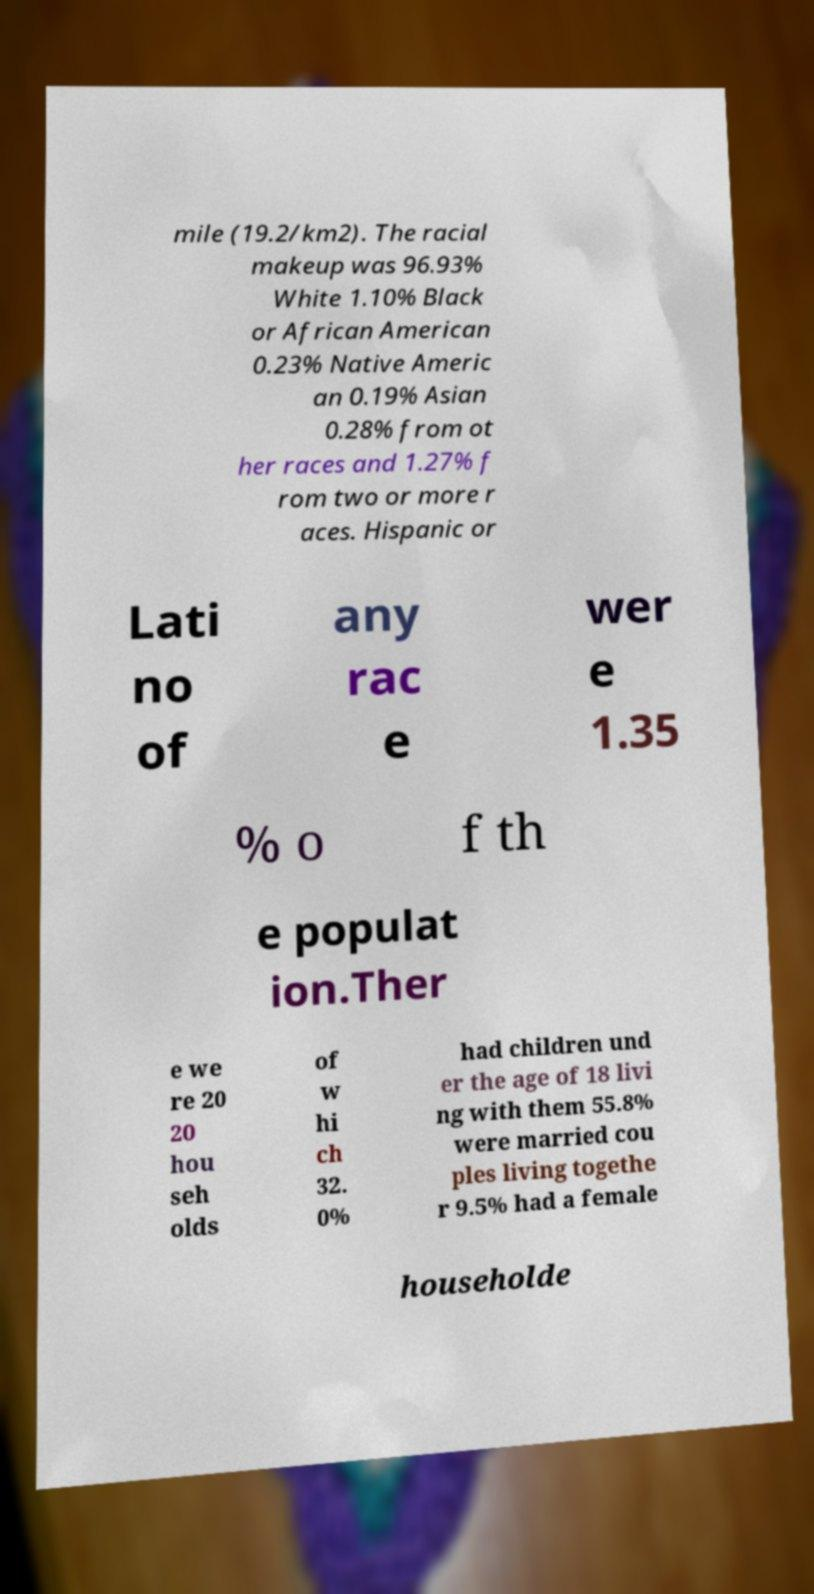Can you accurately transcribe the text from the provided image for me? mile (19.2/km2). The racial makeup was 96.93% White 1.10% Black or African American 0.23% Native Americ an 0.19% Asian 0.28% from ot her races and 1.27% f rom two or more r aces. Hispanic or Lati no of any rac e wer e 1.35 % o f th e populat ion.Ther e we re 20 20 hou seh olds of w hi ch 32. 0% had children und er the age of 18 livi ng with them 55.8% were married cou ples living togethe r 9.5% had a female householde 